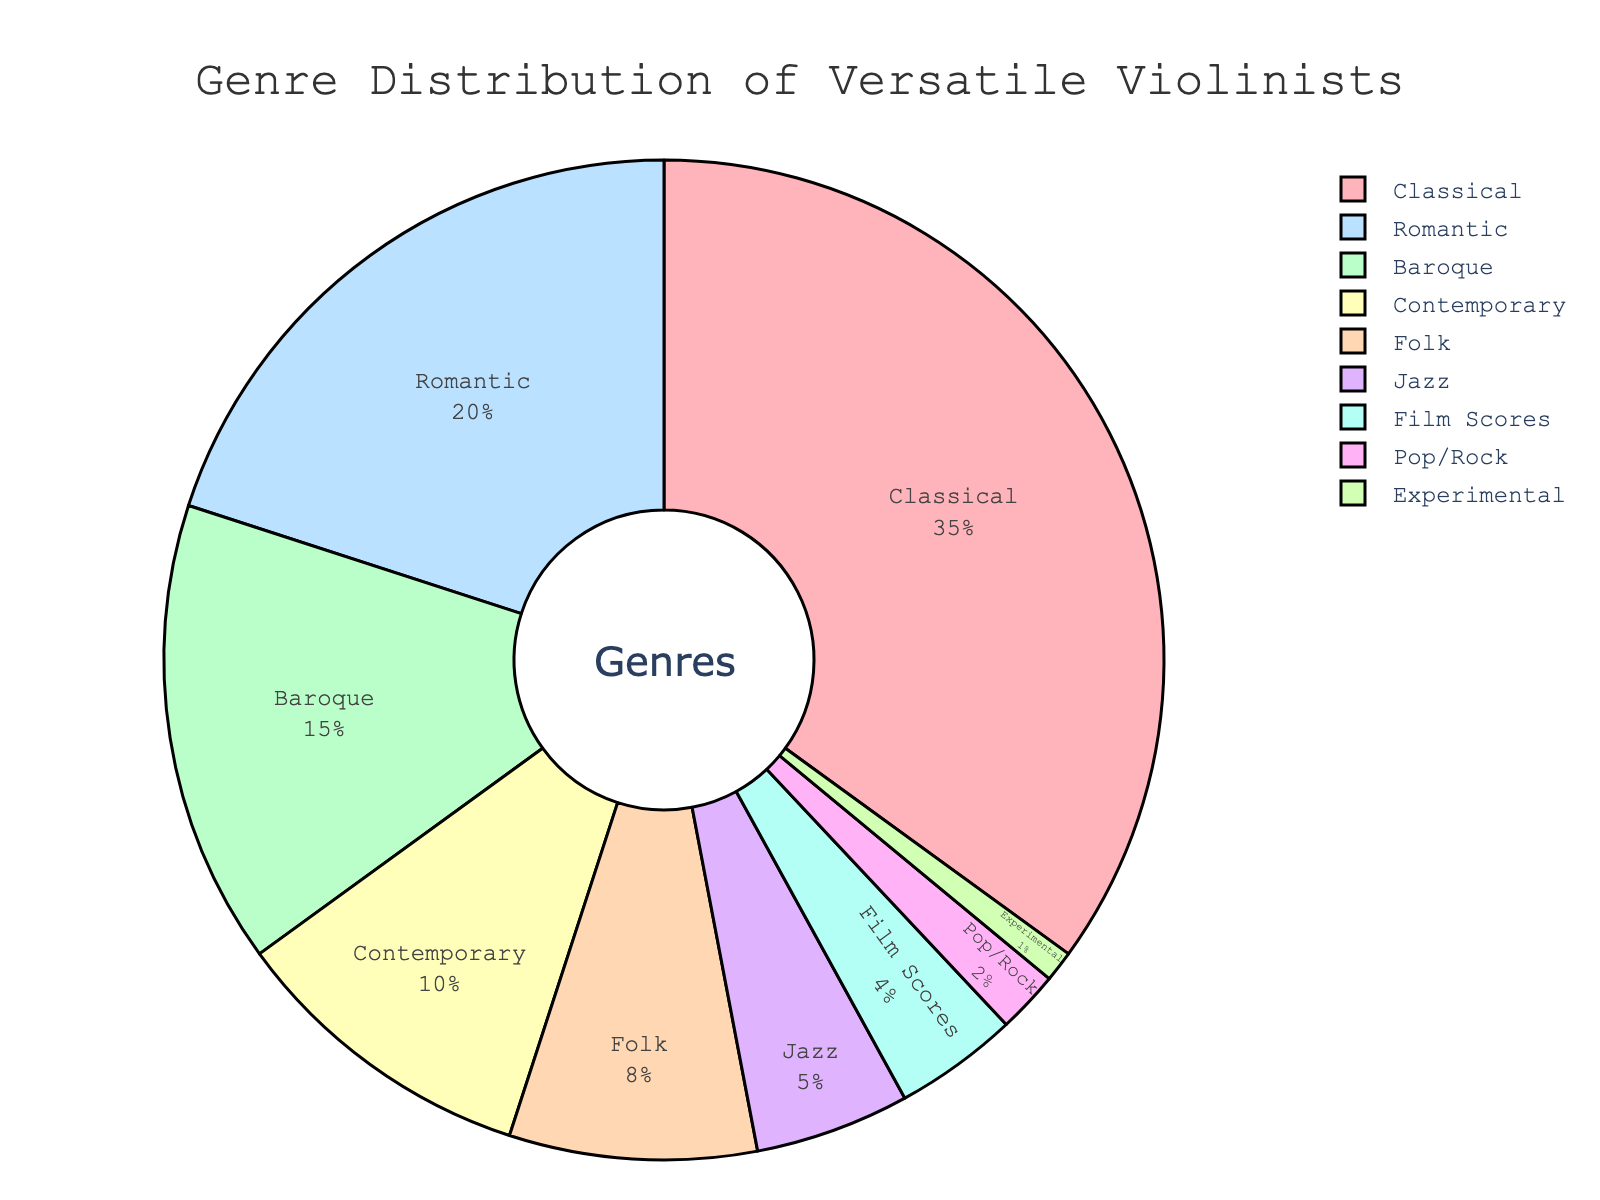What genre occupies the largest slice of the pie chart? The largest slice correlates with the highest percentage. Classical music occupies 35%, which is the highest percentage in the chart.
Answer: Classical What is the combined percentage of Baroque and Romantic genres? Baroque accounts for 15%, and Romantic accounts for 20%. Adding these together gives 15 + 20 = 35%.
Answer: 35 Which genres cumulatively cover more than 50% of the pie chart? Summing the percentages of each genre starting from the largest: Classical (35%) + Romantic (20%) = 55%, which is greater than 50%. Thus, Classical and Romantic together cover more than 50%.
Answer: Classical and Romantic How does the representation of Contemporary compare to Folk in the pie chart? Contemporary covers 10% while Folk covers 8%. Comparing these, Contemporary has a higher percentage than Folk.
Answer: Contemporary > Folk Is the combined percentage of Folk, Jazz, Film Scores, Pop/Rock, and Experimental greater than Classical? Adding the percentages: Folk (8%) + Jazz (5%) + Film Scores (4%) + Pop/Rock (2%) + Experimental (1%) equals 8 + 5 + 4 + 2 + 1 = 20%. Classical alone is 35%. Thus, 20% is less than 35%.
Answer: No What is the total percentage covered by genres other than Classical, Romantic, and Baroque? The percentages for genres apart from Classical (35%), Romantic (20%), and Baroque (15%) sum to 100 - (35 + 20 + 15) = 100 - 70 = 30%.
Answer: 30 Which genre has the smallest representation in the pie chart? The smallest percentage represents the smallest slice. Experimental music has a 1% representation, which is the smallest.
Answer: Experimental If you combine the percentages of Jazz and Film Scores, how does this compare to the percentage of the Baroque genre? Jazz is 5%, and Film Scores is 4%. Sum these to get 5 + 4 = 9%. Baroque is represented by 15%. Thus, 9% is less than 15%.
Answer: < Baroque What percentage of genres fall under 10% representation each? Folk (8%), Jazz (5%), Film Scores (4%), Pop/Rock (2%), and Experimental (1%) all have less than 10% representation each. Summing these, 8 + 5 + 4 + 2 + 1 = 20%.
Answer: 20 